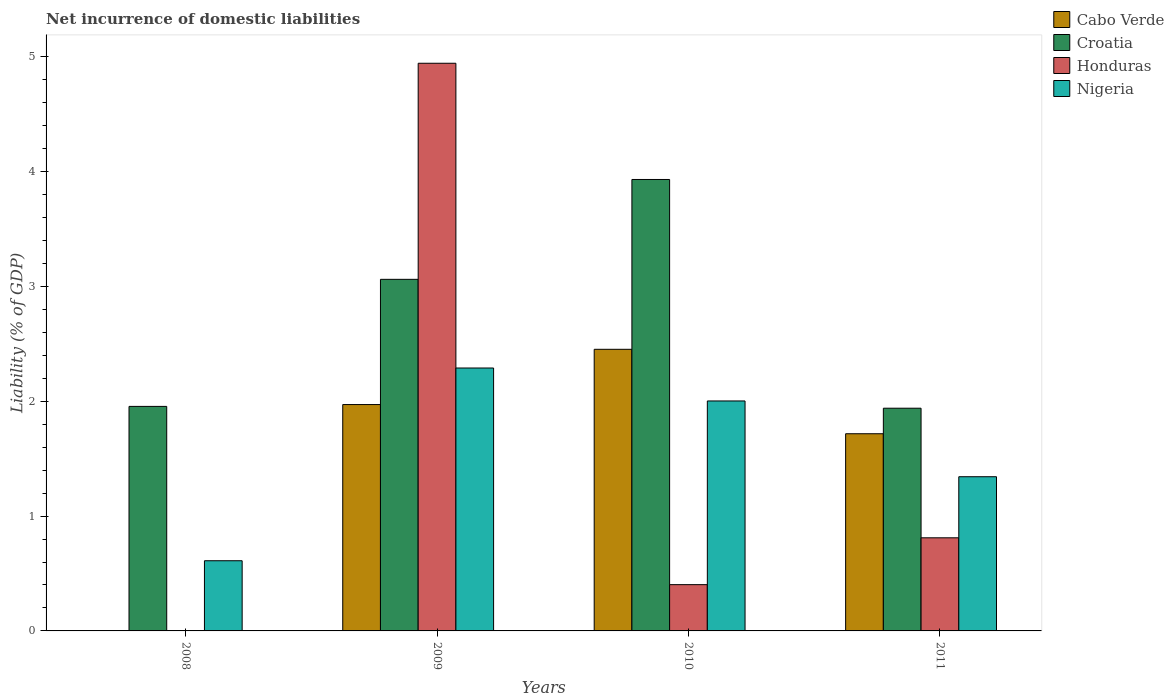How many different coloured bars are there?
Your answer should be compact. 4. Are the number of bars on each tick of the X-axis equal?
Provide a succinct answer. No. What is the label of the 2nd group of bars from the left?
Make the answer very short. 2009. In how many cases, is the number of bars for a given year not equal to the number of legend labels?
Offer a very short reply. 1. What is the net incurrence of domestic liabilities in Croatia in 2011?
Ensure brevity in your answer.  1.94. Across all years, what is the maximum net incurrence of domestic liabilities in Croatia?
Offer a very short reply. 3.93. Across all years, what is the minimum net incurrence of domestic liabilities in Croatia?
Make the answer very short. 1.94. In which year was the net incurrence of domestic liabilities in Croatia maximum?
Keep it short and to the point. 2010. What is the total net incurrence of domestic liabilities in Honduras in the graph?
Offer a very short reply. 6.16. What is the difference between the net incurrence of domestic liabilities in Honduras in 2010 and that in 2011?
Your response must be concise. -0.41. What is the difference between the net incurrence of domestic liabilities in Honduras in 2011 and the net incurrence of domestic liabilities in Croatia in 2008?
Keep it short and to the point. -1.14. What is the average net incurrence of domestic liabilities in Croatia per year?
Keep it short and to the point. 2.72. In the year 2010, what is the difference between the net incurrence of domestic liabilities in Croatia and net incurrence of domestic liabilities in Honduras?
Provide a short and direct response. 3.53. In how many years, is the net incurrence of domestic liabilities in Croatia greater than 0.4 %?
Your answer should be very brief. 4. What is the ratio of the net incurrence of domestic liabilities in Honduras in 2009 to that in 2010?
Your response must be concise. 12.27. Is the difference between the net incurrence of domestic liabilities in Croatia in 2009 and 2011 greater than the difference between the net incurrence of domestic liabilities in Honduras in 2009 and 2011?
Provide a succinct answer. No. What is the difference between the highest and the second highest net incurrence of domestic liabilities in Croatia?
Provide a short and direct response. 0.87. What is the difference between the highest and the lowest net incurrence of domestic liabilities in Cabo Verde?
Your answer should be compact. 2.45. Is it the case that in every year, the sum of the net incurrence of domestic liabilities in Cabo Verde and net incurrence of domestic liabilities in Nigeria is greater than the sum of net incurrence of domestic liabilities in Honduras and net incurrence of domestic liabilities in Croatia?
Offer a very short reply. No. How many bars are there?
Ensure brevity in your answer.  14. What is the difference between two consecutive major ticks on the Y-axis?
Keep it short and to the point. 1. Are the values on the major ticks of Y-axis written in scientific E-notation?
Offer a terse response. No. Does the graph contain grids?
Offer a very short reply. No. Where does the legend appear in the graph?
Provide a short and direct response. Top right. How many legend labels are there?
Provide a succinct answer. 4. How are the legend labels stacked?
Ensure brevity in your answer.  Vertical. What is the title of the graph?
Keep it short and to the point. Net incurrence of domestic liabilities. Does "High income: OECD" appear as one of the legend labels in the graph?
Give a very brief answer. No. What is the label or title of the Y-axis?
Provide a succinct answer. Liability (% of GDP). What is the Liability (% of GDP) in Croatia in 2008?
Keep it short and to the point. 1.95. What is the Liability (% of GDP) in Honduras in 2008?
Your response must be concise. 0. What is the Liability (% of GDP) in Nigeria in 2008?
Your answer should be very brief. 0.61. What is the Liability (% of GDP) of Cabo Verde in 2009?
Offer a very short reply. 1.97. What is the Liability (% of GDP) in Croatia in 2009?
Give a very brief answer. 3.06. What is the Liability (% of GDP) of Honduras in 2009?
Provide a succinct answer. 4.94. What is the Liability (% of GDP) in Nigeria in 2009?
Your response must be concise. 2.29. What is the Liability (% of GDP) in Cabo Verde in 2010?
Give a very brief answer. 2.45. What is the Liability (% of GDP) of Croatia in 2010?
Your answer should be compact. 3.93. What is the Liability (% of GDP) of Honduras in 2010?
Give a very brief answer. 0.4. What is the Liability (% of GDP) in Nigeria in 2010?
Provide a succinct answer. 2. What is the Liability (% of GDP) in Cabo Verde in 2011?
Provide a succinct answer. 1.72. What is the Liability (% of GDP) of Croatia in 2011?
Keep it short and to the point. 1.94. What is the Liability (% of GDP) in Honduras in 2011?
Your response must be concise. 0.81. What is the Liability (% of GDP) in Nigeria in 2011?
Your answer should be compact. 1.34. Across all years, what is the maximum Liability (% of GDP) of Cabo Verde?
Keep it short and to the point. 2.45. Across all years, what is the maximum Liability (% of GDP) of Croatia?
Offer a very short reply. 3.93. Across all years, what is the maximum Liability (% of GDP) in Honduras?
Offer a very short reply. 4.94. Across all years, what is the maximum Liability (% of GDP) in Nigeria?
Keep it short and to the point. 2.29. Across all years, what is the minimum Liability (% of GDP) of Croatia?
Offer a very short reply. 1.94. Across all years, what is the minimum Liability (% of GDP) of Nigeria?
Provide a short and direct response. 0.61. What is the total Liability (% of GDP) in Cabo Verde in the graph?
Your response must be concise. 6.14. What is the total Liability (% of GDP) of Croatia in the graph?
Offer a terse response. 10.88. What is the total Liability (% of GDP) of Honduras in the graph?
Your answer should be very brief. 6.16. What is the total Liability (% of GDP) in Nigeria in the graph?
Keep it short and to the point. 6.24. What is the difference between the Liability (% of GDP) in Croatia in 2008 and that in 2009?
Ensure brevity in your answer.  -1.11. What is the difference between the Liability (% of GDP) in Nigeria in 2008 and that in 2009?
Your response must be concise. -1.68. What is the difference between the Liability (% of GDP) in Croatia in 2008 and that in 2010?
Offer a terse response. -1.98. What is the difference between the Liability (% of GDP) in Nigeria in 2008 and that in 2010?
Ensure brevity in your answer.  -1.39. What is the difference between the Liability (% of GDP) in Croatia in 2008 and that in 2011?
Make the answer very short. 0.02. What is the difference between the Liability (% of GDP) of Nigeria in 2008 and that in 2011?
Provide a short and direct response. -0.73. What is the difference between the Liability (% of GDP) of Cabo Verde in 2009 and that in 2010?
Your answer should be very brief. -0.48. What is the difference between the Liability (% of GDP) in Croatia in 2009 and that in 2010?
Your response must be concise. -0.87. What is the difference between the Liability (% of GDP) in Honduras in 2009 and that in 2010?
Provide a short and direct response. 4.54. What is the difference between the Liability (% of GDP) of Nigeria in 2009 and that in 2010?
Give a very brief answer. 0.29. What is the difference between the Liability (% of GDP) in Cabo Verde in 2009 and that in 2011?
Offer a very short reply. 0.25. What is the difference between the Liability (% of GDP) in Croatia in 2009 and that in 2011?
Provide a short and direct response. 1.12. What is the difference between the Liability (% of GDP) of Honduras in 2009 and that in 2011?
Ensure brevity in your answer.  4.13. What is the difference between the Liability (% of GDP) in Nigeria in 2009 and that in 2011?
Keep it short and to the point. 0.95. What is the difference between the Liability (% of GDP) of Cabo Verde in 2010 and that in 2011?
Offer a very short reply. 0.74. What is the difference between the Liability (% of GDP) in Croatia in 2010 and that in 2011?
Offer a very short reply. 1.99. What is the difference between the Liability (% of GDP) in Honduras in 2010 and that in 2011?
Your answer should be compact. -0.41. What is the difference between the Liability (% of GDP) in Nigeria in 2010 and that in 2011?
Give a very brief answer. 0.66. What is the difference between the Liability (% of GDP) of Croatia in 2008 and the Liability (% of GDP) of Honduras in 2009?
Offer a terse response. -2.99. What is the difference between the Liability (% of GDP) in Croatia in 2008 and the Liability (% of GDP) in Nigeria in 2009?
Offer a terse response. -0.33. What is the difference between the Liability (% of GDP) in Croatia in 2008 and the Liability (% of GDP) in Honduras in 2010?
Keep it short and to the point. 1.55. What is the difference between the Liability (% of GDP) of Croatia in 2008 and the Liability (% of GDP) of Nigeria in 2010?
Offer a terse response. -0.05. What is the difference between the Liability (% of GDP) of Croatia in 2008 and the Liability (% of GDP) of Honduras in 2011?
Keep it short and to the point. 1.14. What is the difference between the Liability (% of GDP) in Croatia in 2008 and the Liability (% of GDP) in Nigeria in 2011?
Give a very brief answer. 0.61. What is the difference between the Liability (% of GDP) in Cabo Verde in 2009 and the Liability (% of GDP) in Croatia in 2010?
Provide a succinct answer. -1.96. What is the difference between the Liability (% of GDP) in Cabo Verde in 2009 and the Liability (% of GDP) in Honduras in 2010?
Provide a succinct answer. 1.57. What is the difference between the Liability (% of GDP) in Cabo Verde in 2009 and the Liability (% of GDP) in Nigeria in 2010?
Your response must be concise. -0.03. What is the difference between the Liability (% of GDP) in Croatia in 2009 and the Liability (% of GDP) in Honduras in 2010?
Your response must be concise. 2.66. What is the difference between the Liability (% of GDP) of Croatia in 2009 and the Liability (% of GDP) of Nigeria in 2010?
Offer a terse response. 1.06. What is the difference between the Liability (% of GDP) in Honduras in 2009 and the Liability (% of GDP) in Nigeria in 2010?
Give a very brief answer. 2.94. What is the difference between the Liability (% of GDP) of Cabo Verde in 2009 and the Liability (% of GDP) of Croatia in 2011?
Make the answer very short. 0.03. What is the difference between the Liability (% of GDP) of Cabo Verde in 2009 and the Liability (% of GDP) of Honduras in 2011?
Offer a terse response. 1.16. What is the difference between the Liability (% of GDP) in Cabo Verde in 2009 and the Liability (% of GDP) in Nigeria in 2011?
Offer a very short reply. 0.63. What is the difference between the Liability (% of GDP) of Croatia in 2009 and the Liability (% of GDP) of Honduras in 2011?
Ensure brevity in your answer.  2.25. What is the difference between the Liability (% of GDP) of Croatia in 2009 and the Liability (% of GDP) of Nigeria in 2011?
Give a very brief answer. 1.72. What is the difference between the Liability (% of GDP) in Honduras in 2009 and the Liability (% of GDP) in Nigeria in 2011?
Make the answer very short. 3.6. What is the difference between the Liability (% of GDP) of Cabo Verde in 2010 and the Liability (% of GDP) of Croatia in 2011?
Make the answer very short. 0.51. What is the difference between the Liability (% of GDP) in Cabo Verde in 2010 and the Liability (% of GDP) in Honduras in 2011?
Keep it short and to the point. 1.64. What is the difference between the Liability (% of GDP) of Cabo Verde in 2010 and the Liability (% of GDP) of Nigeria in 2011?
Your answer should be compact. 1.11. What is the difference between the Liability (% of GDP) of Croatia in 2010 and the Liability (% of GDP) of Honduras in 2011?
Your response must be concise. 3.12. What is the difference between the Liability (% of GDP) in Croatia in 2010 and the Liability (% of GDP) in Nigeria in 2011?
Your response must be concise. 2.59. What is the difference between the Liability (% of GDP) of Honduras in 2010 and the Liability (% of GDP) of Nigeria in 2011?
Your answer should be compact. -0.94. What is the average Liability (% of GDP) of Cabo Verde per year?
Make the answer very short. 1.53. What is the average Liability (% of GDP) in Croatia per year?
Your answer should be compact. 2.72. What is the average Liability (% of GDP) in Honduras per year?
Offer a very short reply. 1.54. What is the average Liability (% of GDP) of Nigeria per year?
Offer a terse response. 1.56. In the year 2008, what is the difference between the Liability (% of GDP) of Croatia and Liability (% of GDP) of Nigeria?
Offer a very short reply. 1.34. In the year 2009, what is the difference between the Liability (% of GDP) in Cabo Verde and Liability (% of GDP) in Croatia?
Provide a short and direct response. -1.09. In the year 2009, what is the difference between the Liability (% of GDP) of Cabo Verde and Liability (% of GDP) of Honduras?
Your response must be concise. -2.97. In the year 2009, what is the difference between the Liability (% of GDP) of Cabo Verde and Liability (% of GDP) of Nigeria?
Ensure brevity in your answer.  -0.32. In the year 2009, what is the difference between the Liability (% of GDP) in Croatia and Liability (% of GDP) in Honduras?
Offer a very short reply. -1.88. In the year 2009, what is the difference between the Liability (% of GDP) of Croatia and Liability (% of GDP) of Nigeria?
Offer a very short reply. 0.77. In the year 2009, what is the difference between the Liability (% of GDP) of Honduras and Liability (% of GDP) of Nigeria?
Ensure brevity in your answer.  2.65. In the year 2010, what is the difference between the Liability (% of GDP) of Cabo Verde and Liability (% of GDP) of Croatia?
Offer a very short reply. -1.48. In the year 2010, what is the difference between the Liability (% of GDP) in Cabo Verde and Liability (% of GDP) in Honduras?
Make the answer very short. 2.05. In the year 2010, what is the difference between the Liability (% of GDP) of Cabo Verde and Liability (% of GDP) of Nigeria?
Your answer should be very brief. 0.45. In the year 2010, what is the difference between the Liability (% of GDP) in Croatia and Liability (% of GDP) in Honduras?
Keep it short and to the point. 3.53. In the year 2010, what is the difference between the Liability (% of GDP) in Croatia and Liability (% of GDP) in Nigeria?
Provide a succinct answer. 1.93. In the year 2010, what is the difference between the Liability (% of GDP) of Honduras and Liability (% of GDP) of Nigeria?
Your answer should be very brief. -1.6. In the year 2011, what is the difference between the Liability (% of GDP) in Cabo Verde and Liability (% of GDP) in Croatia?
Your response must be concise. -0.22. In the year 2011, what is the difference between the Liability (% of GDP) of Cabo Verde and Liability (% of GDP) of Honduras?
Give a very brief answer. 0.91. In the year 2011, what is the difference between the Liability (% of GDP) in Cabo Verde and Liability (% of GDP) in Nigeria?
Offer a terse response. 0.37. In the year 2011, what is the difference between the Liability (% of GDP) of Croatia and Liability (% of GDP) of Honduras?
Ensure brevity in your answer.  1.13. In the year 2011, what is the difference between the Liability (% of GDP) in Croatia and Liability (% of GDP) in Nigeria?
Your answer should be very brief. 0.6. In the year 2011, what is the difference between the Liability (% of GDP) of Honduras and Liability (% of GDP) of Nigeria?
Your response must be concise. -0.53. What is the ratio of the Liability (% of GDP) of Croatia in 2008 to that in 2009?
Give a very brief answer. 0.64. What is the ratio of the Liability (% of GDP) of Nigeria in 2008 to that in 2009?
Keep it short and to the point. 0.27. What is the ratio of the Liability (% of GDP) in Croatia in 2008 to that in 2010?
Offer a terse response. 0.5. What is the ratio of the Liability (% of GDP) in Nigeria in 2008 to that in 2010?
Make the answer very short. 0.31. What is the ratio of the Liability (% of GDP) of Nigeria in 2008 to that in 2011?
Ensure brevity in your answer.  0.46. What is the ratio of the Liability (% of GDP) in Cabo Verde in 2009 to that in 2010?
Your answer should be very brief. 0.8. What is the ratio of the Liability (% of GDP) in Croatia in 2009 to that in 2010?
Your response must be concise. 0.78. What is the ratio of the Liability (% of GDP) of Honduras in 2009 to that in 2010?
Make the answer very short. 12.27. What is the ratio of the Liability (% of GDP) in Nigeria in 2009 to that in 2010?
Provide a short and direct response. 1.14. What is the ratio of the Liability (% of GDP) in Cabo Verde in 2009 to that in 2011?
Your answer should be compact. 1.15. What is the ratio of the Liability (% of GDP) in Croatia in 2009 to that in 2011?
Give a very brief answer. 1.58. What is the ratio of the Liability (% of GDP) of Honduras in 2009 to that in 2011?
Provide a succinct answer. 6.1. What is the ratio of the Liability (% of GDP) of Nigeria in 2009 to that in 2011?
Give a very brief answer. 1.71. What is the ratio of the Liability (% of GDP) in Cabo Verde in 2010 to that in 2011?
Provide a succinct answer. 1.43. What is the ratio of the Liability (% of GDP) in Croatia in 2010 to that in 2011?
Your answer should be very brief. 2.03. What is the ratio of the Liability (% of GDP) in Honduras in 2010 to that in 2011?
Your answer should be compact. 0.5. What is the ratio of the Liability (% of GDP) in Nigeria in 2010 to that in 2011?
Your answer should be compact. 1.49. What is the difference between the highest and the second highest Liability (% of GDP) in Cabo Verde?
Keep it short and to the point. 0.48. What is the difference between the highest and the second highest Liability (% of GDP) of Croatia?
Give a very brief answer. 0.87. What is the difference between the highest and the second highest Liability (% of GDP) of Honduras?
Make the answer very short. 4.13. What is the difference between the highest and the second highest Liability (% of GDP) of Nigeria?
Give a very brief answer. 0.29. What is the difference between the highest and the lowest Liability (% of GDP) in Cabo Verde?
Provide a succinct answer. 2.45. What is the difference between the highest and the lowest Liability (% of GDP) in Croatia?
Ensure brevity in your answer.  1.99. What is the difference between the highest and the lowest Liability (% of GDP) of Honduras?
Ensure brevity in your answer.  4.94. What is the difference between the highest and the lowest Liability (% of GDP) of Nigeria?
Your response must be concise. 1.68. 